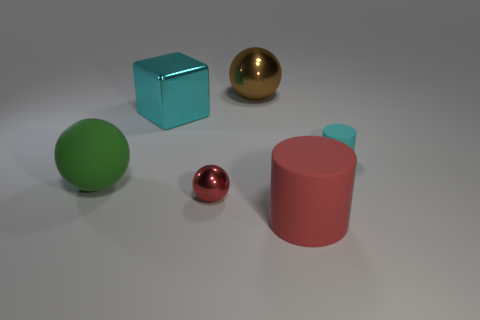Is the shape of the small cyan rubber thing the same as the large object in front of the red metal ball?
Make the answer very short. Yes. How many spheres are either tiny red metal things or green things?
Ensure brevity in your answer.  2. There is a cyan object in front of the large block; what is its shape?
Make the answer very short. Cylinder. How many green things have the same material as the cyan cylinder?
Provide a succinct answer. 1. Is the number of large green rubber things that are behind the cyan cube less than the number of large red matte cylinders?
Your answer should be very brief. Yes. There is a cyan object on the right side of the sphere that is behind the cyan matte thing; what is its size?
Your answer should be very brief. Small. There is a big cylinder; does it have the same color as the big matte object that is on the left side of the red cylinder?
Ensure brevity in your answer.  No. There is a cyan block that is the same size as the green matte sphere; what is it made of?
Your answer should be compact. Metal. Is the number of small spheres that are behind the big cyan block less than the number of big rubber cylinders on the right side of the tiny cyan cylinder?
Ensure brevity in your answer.  No. What is the shape of the large green rubber object that is behind the big rubber object that is to the right of the large brown metallic object?
Your answer should be compact. Sphere. 